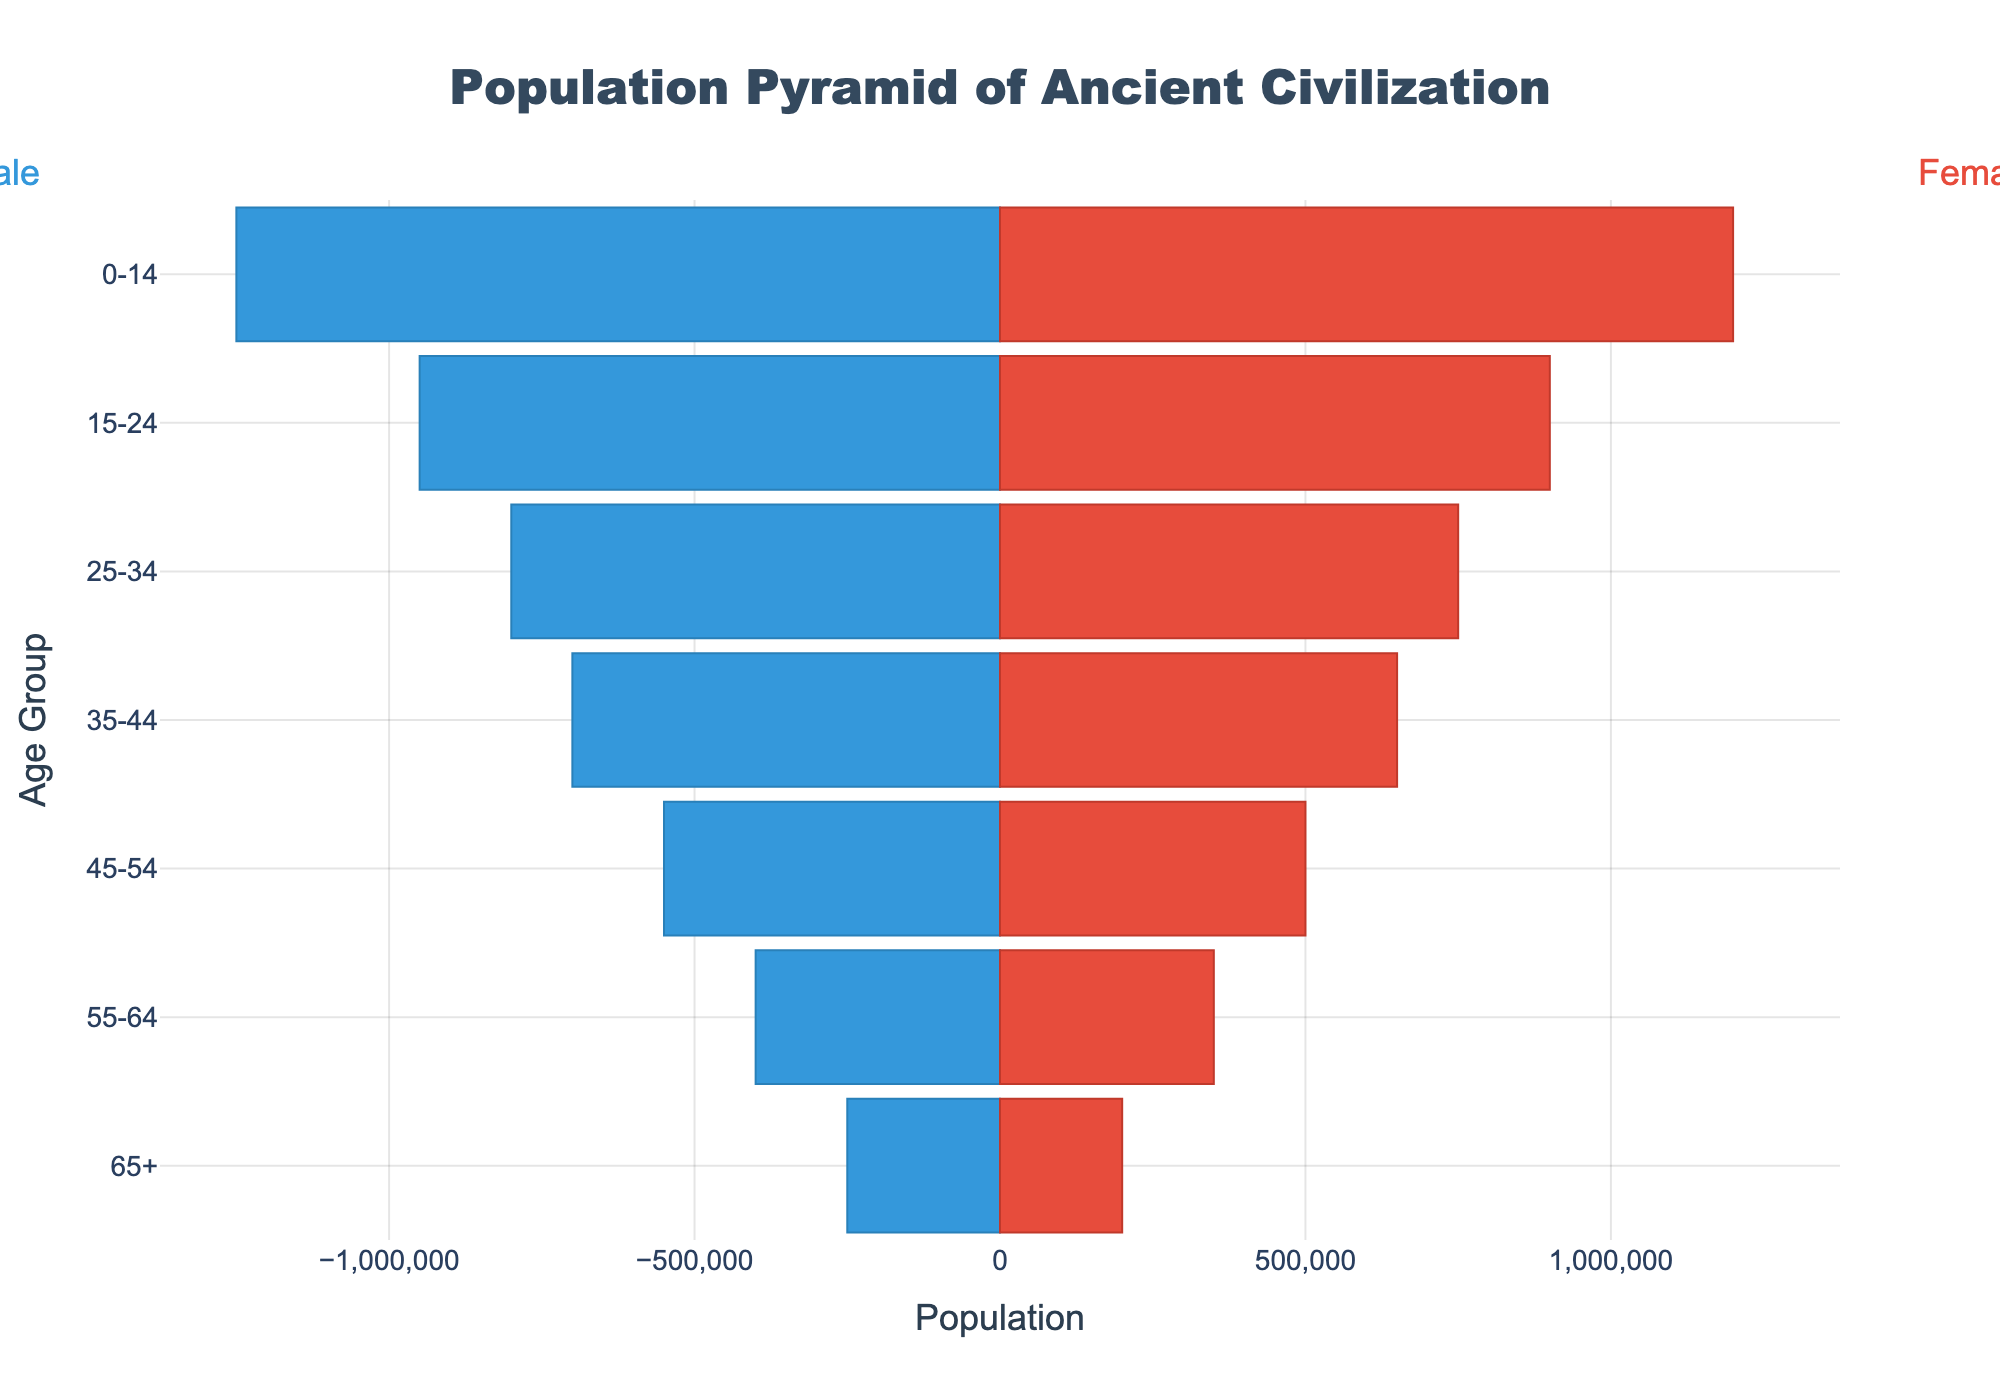What is the title of the figure? The title of the figure is typically found at the top and often gives an overview of what the figure is about. Here, the title is prominently displayed.
Answer: Population Pyramid of Ancient Civilization Which age group has the largest male population? By looking at the length of the bars on the left side of the pyramid, which represents males, we can identify the longest bar.
Answer: 0-14 How does the population of males compare to females in the age group 25-34? We can compare the lengths of the respective bars for both males and females. The male population is represented on the left (negative values), and the female population on the right.
Answer: Males: 800,000, Females: 750,000 What is the total population of the age group 55-64? The total population for the age group 55-64 can be found by summing the populations of both males and females in that group.
Answer: 400,000 + 350,000 = 750,000 Which gender has a larger population in the age group 65+? By comparing the lengths of the bars for the 65+ age group, we see which side (left for males, right for females) has a longer bar.
Answer: Male How does the male population of the age group 0-14 compare to the male population of the age group 45-54? To find the difference, we subtract the population of males in the 45-54 age group from that in the 0-14 age group.
Answer: 1,250,000 - 550,000 = 700,000 What is the percentage difference between the male and female populations in the age group 15-24? Calculate the difference between the male and female populations for the age group 15-24, divide by the male population, and multiply by 100 to get the percentage.
Answer: ((950,000 - 900,000) / 950,000) * 100 ≈ 5.26% What age group has the smallest population and what is the total population of that group? By comparing the lengths of the bars for each age group on both sides of the pyramid, we can identify the group with the smallest combined population.
Answer: Age group: 65+, Total population: 450,000 What is the average female population across all age groups? Sum all the female populations across each age group and then divide by the number of age groups.
Answer: (1,200,000 + 900,000 + 750,000 + 650,000 + 500,000 + 350,000 + 200,000) / 7 ≈ 650,000 Compare the sum of the populations of the age groups 25-34 and 35-44 for both males and females. We find the sum for each age group and each gender and then compare these sums.
Answer: Males: (800,000 + 700,000) = 1,500,000, Females: (750,000 + 650,000) = 1,400,000 